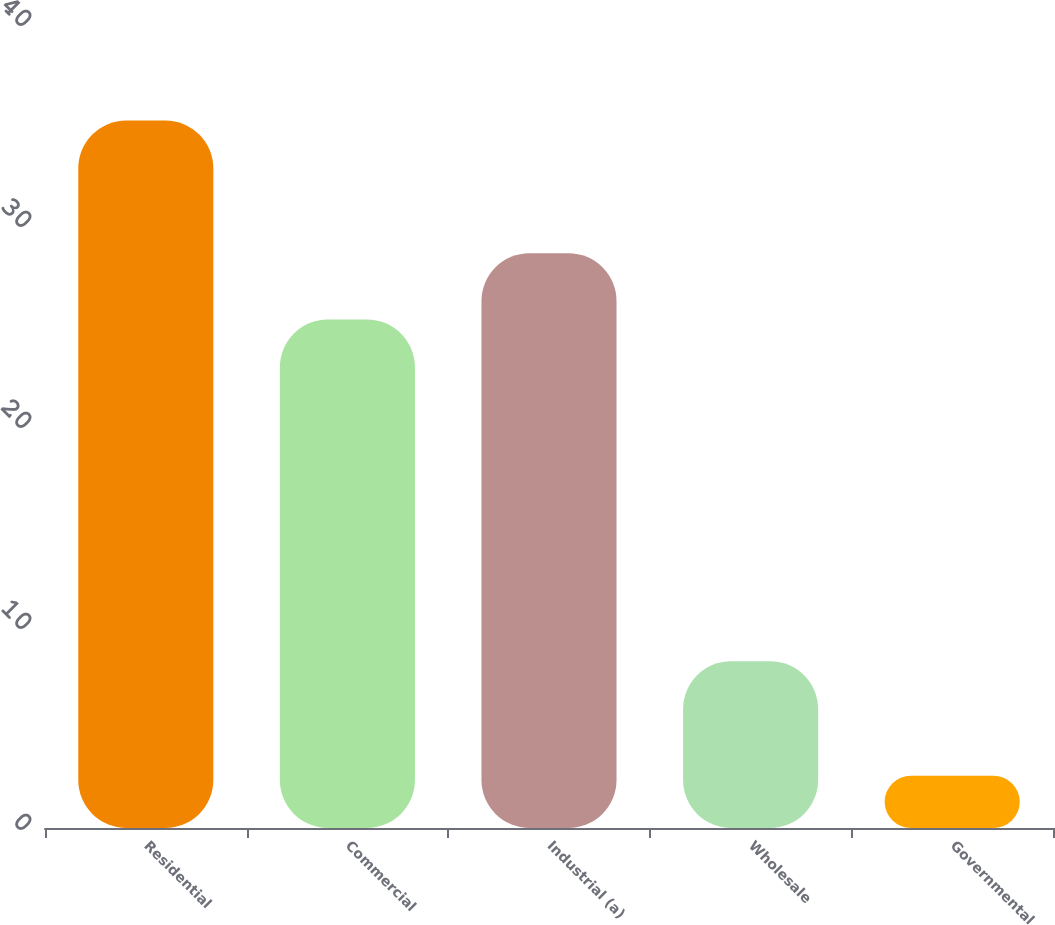Convert chart to OTSL. <chart><loc_0><loc_0><loc_500><loc_500><bar_chart><fcel>Residential<fcel>Commercial<fcel>Industrial (a)<fcel>Wholesale<fcel>Governmental<nl><fcel>35.2<fcel>25.3<fcel>28.6<fcel>8.3<fcel>2.6<nl></chart> 